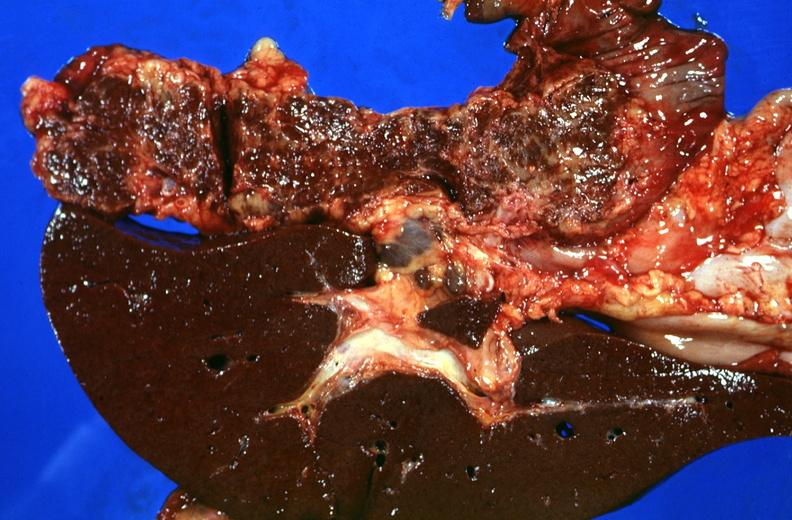does this image show liver and pancreas, hemochromatosis?
Answer the question using a single word or phrase. Yes 